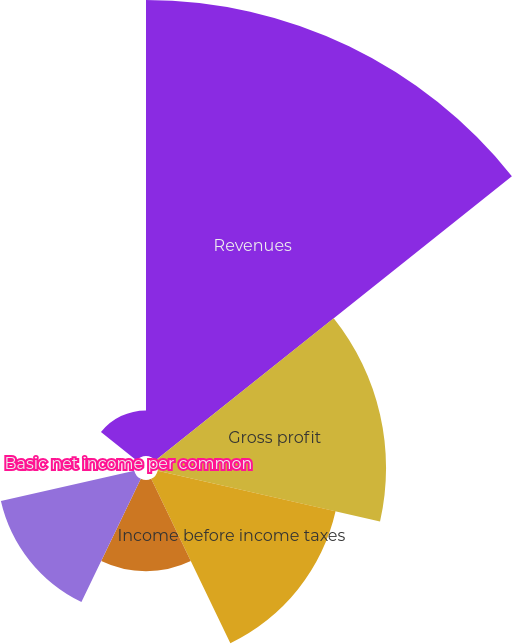Convert chart to OTSL. <chart><loc_0><loc_0><loc_500><loc_500><pie_chart><fcel>Revenues<fcel>Gross profit<fcel>Income before income taxes<fcel>Income tax (benefit) expense<fcel>Net income<fcel>Basic net income per common<fcel>Diluted net income per common<nl><fcel>39.99%<fcel>20.0%<fcel>16.0%<fcel>8.0%<fcel>12.0%<fcel>0.01%<fcel>4.0%<nl></chart> 